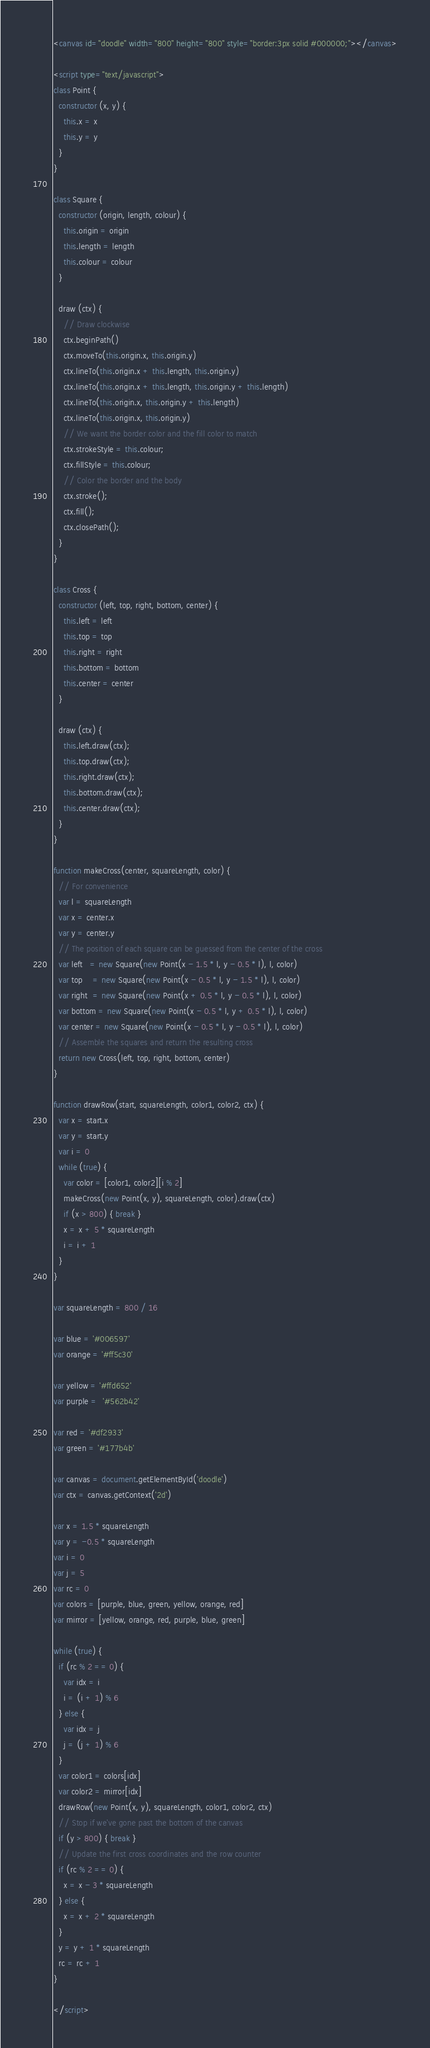<code> <loc_0><loc_0><loc_500><loc_500><_HTML_><canvas id="doodle" width="800" height="800" style="border:3px solid #000000;"></canvas>

<script type="text/javascript">
class Point {
  constructor (x, y) {
    this.x = x
    this.y = y
  }
}

class Square {
  constructor (origin, length, colour) {
    this.origin = origin
    this.length = length
    this.colour = colour
  }

  draw (ctx) {
    // Draw clockwise
    ctx.beginPath()
    ctx.moveTo(this.origin.x, this.origin.y)
    ctx.lineTo(this.origin.x + this.length, this.origin.y)
    ctx.lineTo(this.origin.x + this.length, this.origin.y + this.length)
    ctx.lineTo(this.origin.x, this.origin.y + this.length)
    ctx.lineTo(this.origin.x, this.origin.y)
    // We want the border color and the fill color to match
    ctx.strokeStyle = this.colour;
    ctx.fillStyle = this.colour;
    // Color the border and the body
    ctx.stroke();
    ctx.fill();
    ctx.closePath();
  }
}

class Cross {
  constructor (left, top, right, bottom, center) {
    this.left = left
    this.top = top
    this.right = right
    this.bottom = bottom
    this.center = center
  }

  draw (ctx) {
    this.left.draw(ctx);
    this.top.draw(ctx);
    this.right.draw(ctx);
    this.bottom.draw(ctx);
    this.center.draw(ctx);
  }
}

function makeCross(center, squareLength, color) {
  // For convenience
  var l = squareLength
  var x = center.x
  var y = center.y
  // The position of each square can be guessed from the center of the cross
  var left   = new Square(new Point(x - 1.5 * l, y - 0.5 * l), l, color)
  var top    = new Square(new Point(x - 0.5 * l, y - 1.5 * l), l, color)
  var right  = new Square(new Point(x + 0.5 * l, y - 0.5 * l), l, color)
  var bottom = new Square(new Point(x - 0.5 * l, y + 0.5 * l), l, color)
  var center = new Square(new Point(x - 0.5 * l, y - 0.5 * l), l, color)
  // Assemble the squares and return the resulting cross
  return new Cross(left, top, right, bottom, center)
}

function drawRow(start, squareLength, color1, color2, ctx) {
  var x = start.x
  var y = start.y
  var i = 0
  while (true) {
    var color = [color1, color2][i % 2]
    makeCross(new Point(x, y), squareLength, color).draw(ctx)
    if (x > 800) { break }
    x = x + 5 * squareLength
    i = i + 1
  }
}

var squareLength = 800 / 16

var blue = '#006597'
var orange = '#ff5c30'

var yellow = '#ffd652'
var purple =  '#562b42'

var red = '#df2933'
var green = '#177b4b'

var canvas = document.getElementById('doodle')
var ctx = canvas.getContext('2d')

var x = 1.5 * squareLength
var y = -0.5 * squareLength
var i = 0
var j = 5
var rc = 0
var colors = [purple, blue, green, yellow, orange, red]
var mirror = [yellow, orange, red, purple, blue, green]

while (true) {
  if (rc % 2 == 0) {
    var idx = i
    i = (i + 1) % 6
  } else {
    var idx = j
    j = (j + 1) % 6
  }
  var color1 = colors[idx]
  var color2 = mirror[idx]
  drawRow(new Point(x, y), squareLength, color1, color2, ctx)
  // Stop if we've gone past the bottom of the canvas
  if (y > 800) { break }
  // Update the first cross coordinates and the row counter
  if (rc % 2 == 0) {
    x = x - 3 * squareLength
  } else {
    x = x + 2 * squareLength
  }
  y = y + 1 * squareLength
  rc = rc + 1
}

</script>
</code> 